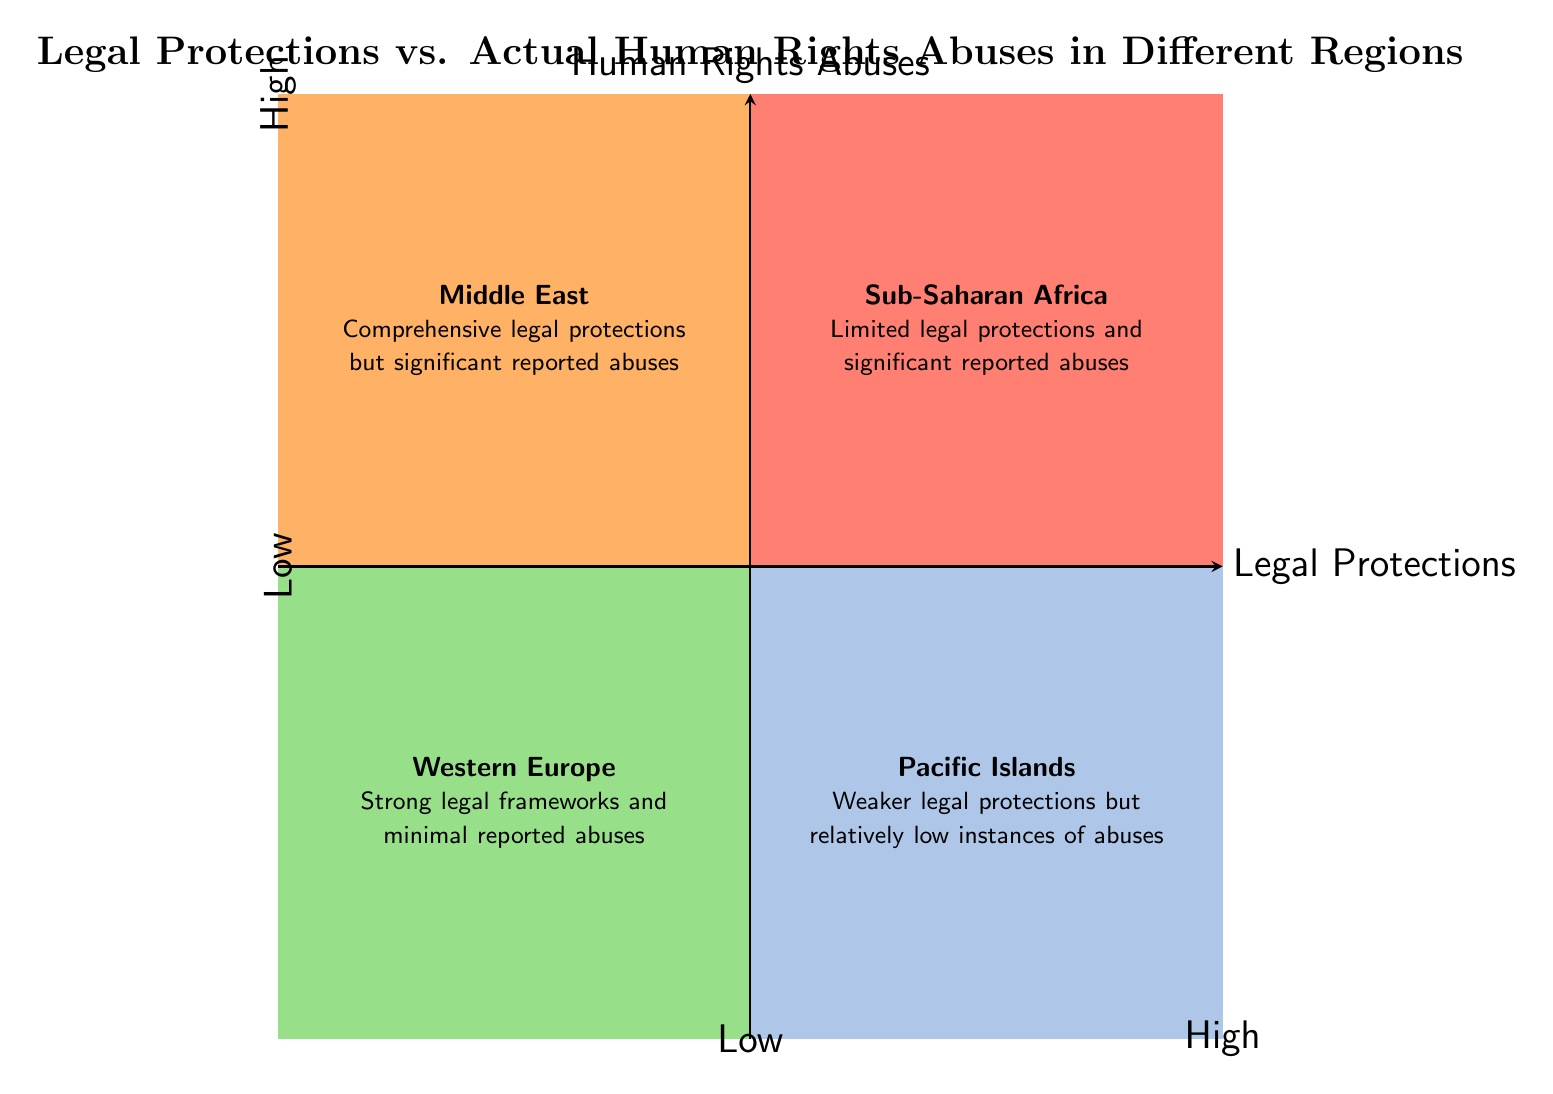What region has strong legal protections and minimal reported abuses? The diagram indicates that Western Europe is in the quadrant representing strong legal frameworks and minimal reported abuses, thus answering the question directly.
Answer: Western Europe Which region demonstrates high human rights abuses despite having legal protections? According to the diagram, the Middle East is situated in the quadrant characterized by comprehensive legal protections but significant reported abuses, thus illustrating the disparity between law and practice.
Answer: Middle East What legal protection level corresponds with Pacific Islands? The Pacific Islands are placed in the quadrant that indicates weaker legal protections with relatively low instances of human rights abuses. This structure helps define the region's legal context.
Answer: Low protections How many regions exhibit high laws but also high abuses? By examining the diagram, it can be observed that there is one region in the high legal protections and high abuses quadrant, which is the Middle East.
Answer: 1 What is the relationship between Sub-Saharan Africa and legal protections? The diagram places Sub-Saharan Africa in the quadrant with limited legal protections and significant reported abuses, underscoring the existing gap needing reform.
Answer: Limited legal protections Which quadrant contains regions with weaker legal protections and lower abuses? The Pacific Islands fall into the quadrant defined by weaker legal protections combined with low recorded instances of human rights abuses, hence fulfilling this criteria.
Answer: Low protections, low abuses What region is identified as having significant human rights abuses and limited legal protections? Sub-Saharan Africa is shown in the quadrant signifying these characteristics, highlighting areas in need of reform and attention.
Answer: Sub-Saharan Africa Which region has both high legal protections and low human rights abuses? The diagram indicates that Western Europe uniquely occupies this position, showcasing a strong alignment between legal frameworks and real-world conditions.
Answer: Western Europe 